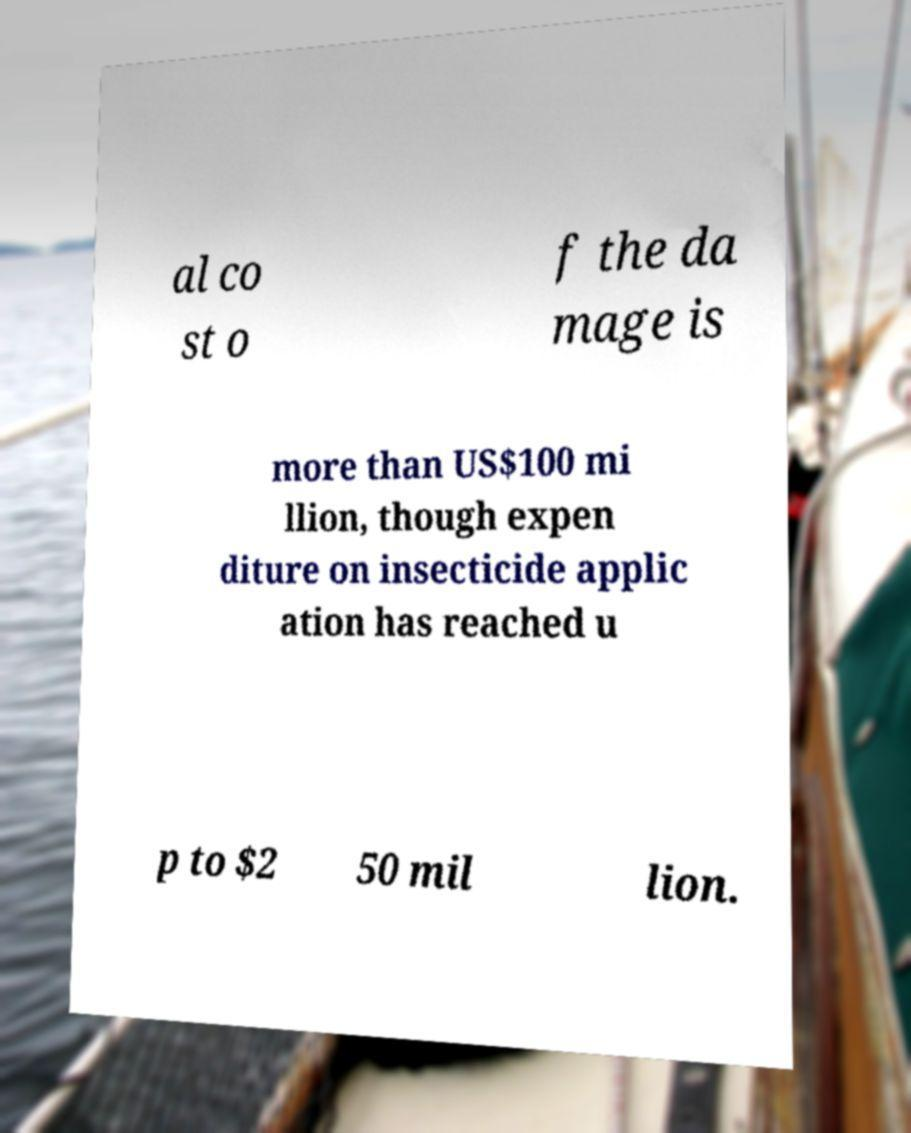Can you read and provide the text displayed in the image?This photo seems to have some interesting text. Can you extract and type it out for me? al co st o f the da mage is more than US$100 mi llion, though expen diture on insecticide applic ation has reached u p to $2 50 mil lion. 